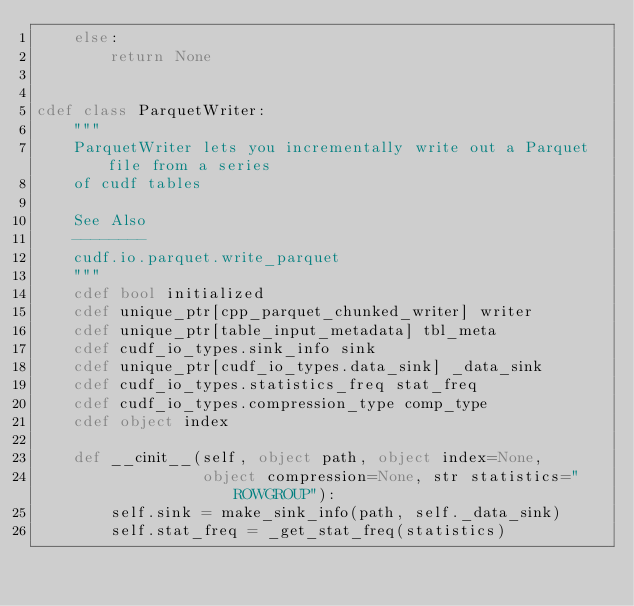<code> <loc_0><loc_0><loc_500><loc_500><_Cython_>    else:
        return None


cdef class ParquetWriter:
    """
    ParquetWriter lets you incrementally write out a Parquet file from a series
    of cudf tables

    See Also
    --------
    cudf.io.parquet.write_parquet
    """
    cdef bool initialized
    cdef unique_ptr[cpp_parquet_chunked_writer] writer
    cdef unique_ptr[table_input_metadata] tbl_meta
    cdef cudf_io_types.sink_info sink
    cdef unique_ptr[cudf_io_types.data_sink] _data_sink
    cdef cudf_io_types.statistics_freq stat_freq
    cdef cudf_io_types.compression_type comp_type
    cdef object index

    def __cinit__(self, object path, object index=None,
                  object compression=None, str statistics="ROWGROUP"):
        self.sink = make_sink_info(path, self._data_sink)
        self.stat_freq = _get_stat_freq(statistics)</code> 